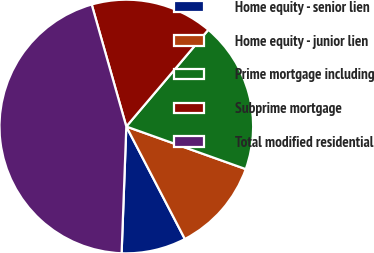<chart> <loc_0><loc_0><loc_500><loc_500><pie_chart><fcel>Home equity - senior lien<fcel>Home equity - junior lien<fcel>Prime mortgage including<fcel>Subprime mortgage<fcel>Total modified residential<nl><fcel>8.23%<fcel>11.91%<fcel>19.26%<fcel>15.59%<fcel>45.01%<nl></chart> 